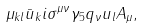<formula> <loc_0><loc_0><loc_500><loc_500>\mu _ { k l } \bar { u } _ { k } i \sigma ^ { \mu \nu } \gamma _ { 5 } q _ { \nu } u _ { l } A _ { \mu } ,</formula> 